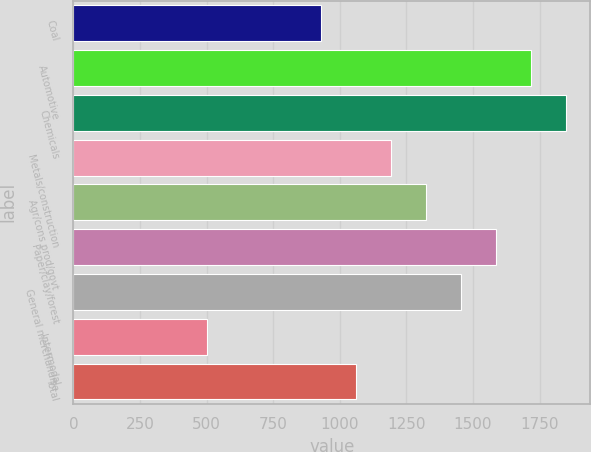<chart> <loc_0><loc_0><loc_500><loc_500><bar_chart><fcel>Coal<fcel>Automotive<fcel>Chemicals<fcel>Metals/construction<fcel>Agr/cons prod/govt<fcel>Paper/clay/forest<fcel>General merchandise<fcel>Intermodal<fcel>Total<nl><fcel>929<fcel>1716.8<fcel>1848.1<fcel>1191.6<fcel>1322.9<fcel>1585.5<fcel>1454.2<fcel>502<fcel>1060.3<nl></chart> 